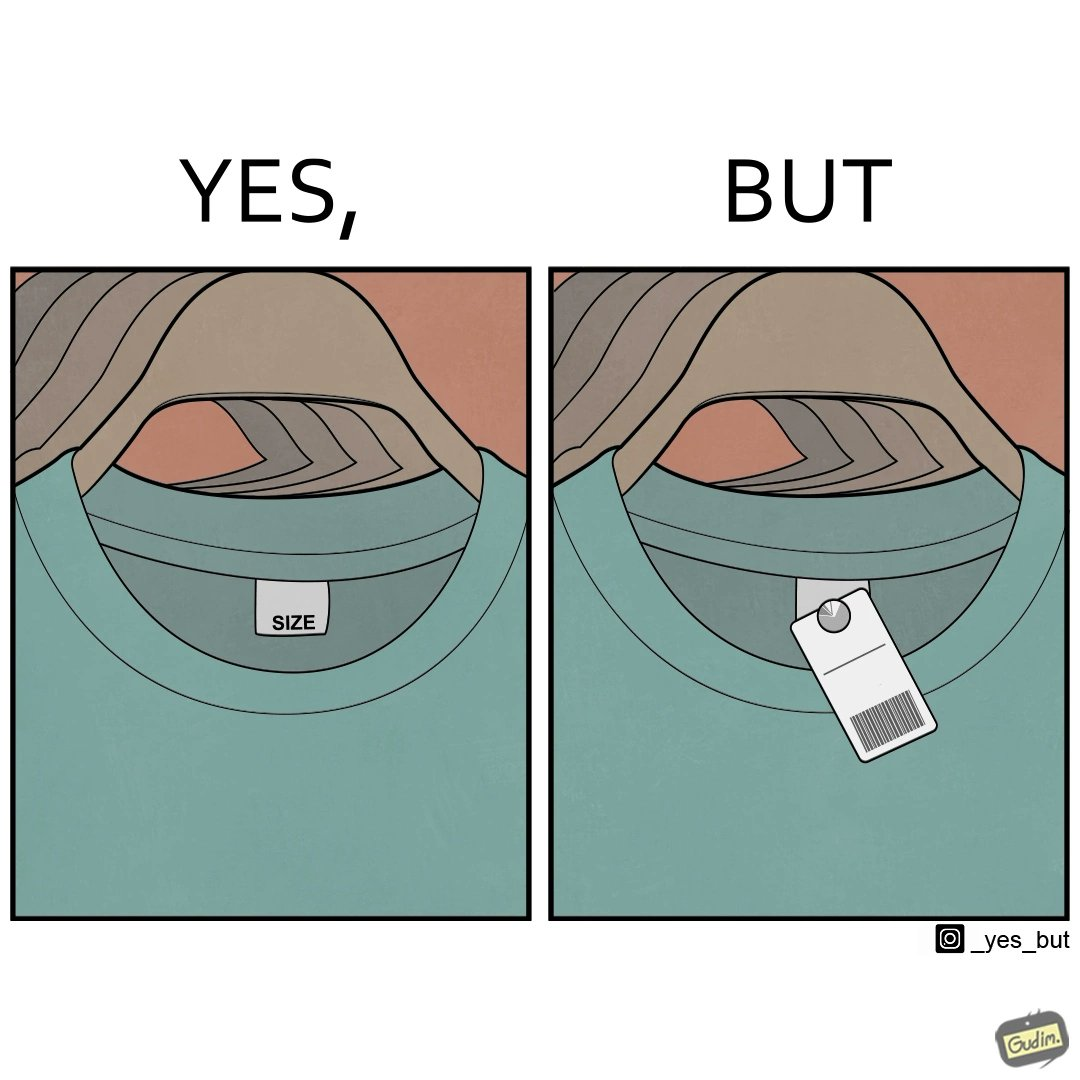Is this image satirical or non-satirical? Yes, this image is satirical. 